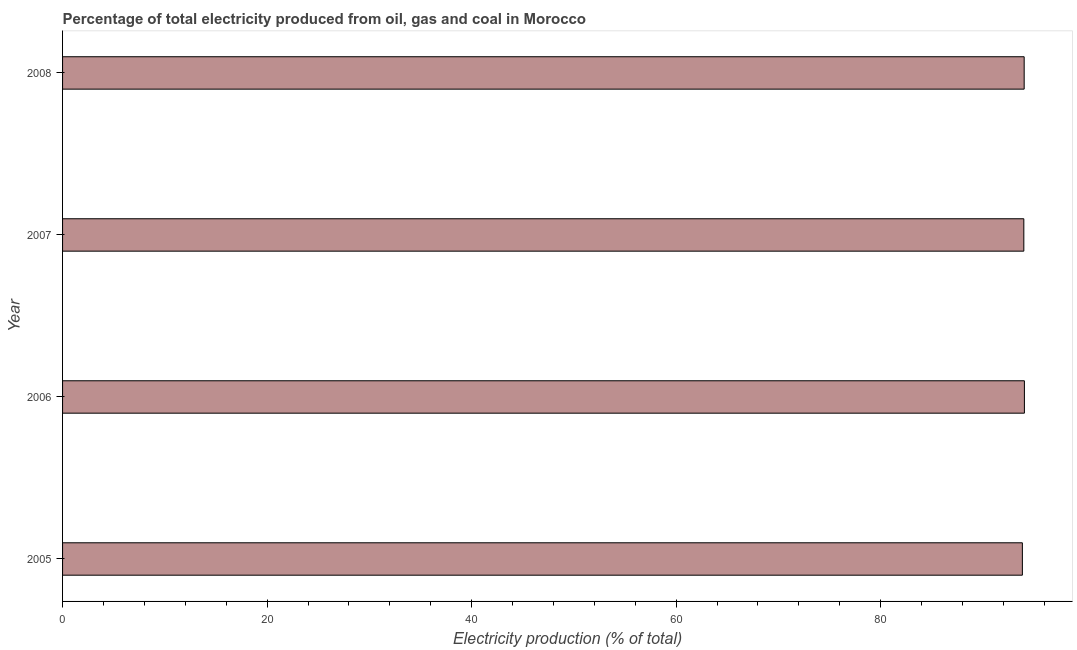Does the graph contain any zero values?
Make the answer very short. No. Does the graph contain grids?
Ensure brevity in your answer.  No. What is the title of the graph?
Offer a terse response. Percentage of total electricity produced from oil, gas and coal in Morocco. What is the label or title of the X-axis?
Provide a short and direct response. Electricity production (% of total). What is the electricity production in 2005?
Offer a terse response. 93.86. Across all years, what is the maximum electricity production?
Give a very brief answer. 94.05. Across all years, what is the minimum electricity production?
Your answer should be very brief. 93.86. In which year was the electricity production maximum?
Keep it short and to the point. 2006. In which year was the electricity production minimum?
Offer a terse response. 2005. What is the sum of the electricity production?
Ensure brevity in your answer.  375.94. What is the difference between the electricity production in 2005 and 2008?
Give a very brief answer. -0.17. What is the average electricity production per year?
Provide a succinct answer. 93.99. What is the median electricity production?
Your response must be concise. 94.02. In how many years, is the electricity production greater than 64 %?
Provide a short and direct response. 4. Do a majority of the years between 2008 and 2006 (inclusive) have electricity production greater than 52 %?
Your answer should be very brief. Yes. What is the ratio of the electricity production in 2005 to that in 2008?
Keep it short and to the point. 1. What is the difference between the highest and the second highest electricity production?
Provide a succinct answer. 0.02. Is the sum of the electricity production in 2005 and 2008 greater than the maximum electricity production across all years?
Offer a very short reply. Yes. In how many years, is the electricity production greater than the average electricity production taken over all years?
Your answer should be compact. 3. How many years are there in the graph?
Ensure brevity in your answer.  4. What is the difference between two consecutive major ticks on the X-axis?
Provide a short and direct response. 20. What is the Electricity production (% of total) in 2005?
Provide a succinct answer. 93.86. What is the Electricity production (% of total) of 2006?
Make the answer very short. 94.05. What is the Electricity production (% of total) of 2007?
Offer a terse response. 94. What is the Electricity production (% of total) of 2008?
Make the answer very short. 94.03. What is the difference between the Electricity production (% of total) in 2005 and 2006?
Your answer should be very brief. -0.2. What is the difference between the Electricity production (% of total) in 2005 and 2007?
Provide a succinct answer. -0.14. What is the difference between the Electricity production (% of total) in 2005 and 2008?
Your answer should be compact. -0.18. What is the difference between the Electricity production (% of total) in 2006 and 2007?
Provide a succinct answer. 0.06. What is the difference between the Electricity production (% of total) in 2006 and 2008?
Offer a very short reply. 0.02. What is the difference between the Electricity production (% of total) in 2007 and 2008?
Give a very brief answer. -0.03. What is the ratio of the Electricity production (% of total) in 2006 to that in 2008?
Give a very brief answer. 1. What is the ratio of the Electricity production (% of total) in 2007 to that in 2008?
Give a very brief answer. 1. 